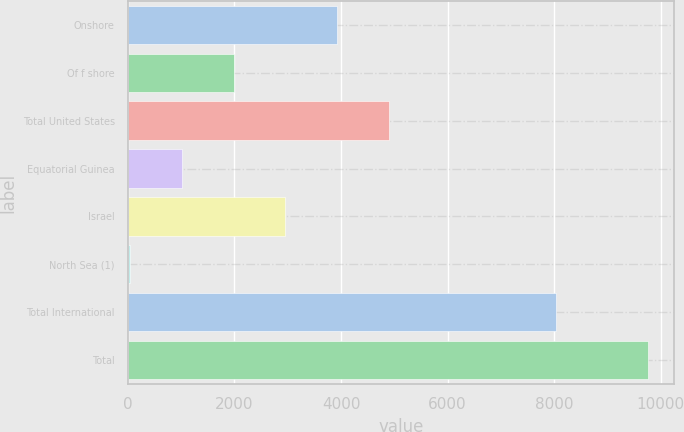Convert chart. <chart><loc_0><loc_0><loc_500><loc_500><bar_chart><fcel>Onshore<fcel>Of f shore<fcel>Total United States<fcel>Equatorial Guinea<fcel>Israel<fcel>North Sea (1)<fcel>Total International<fcel>Total<nl><fcel>3927<fcel>1984<fcel>4898.5<fcel>1012.5<fcel>2955.5<fcel>41<fcel>8041<fcel>9756<nl></chart> 